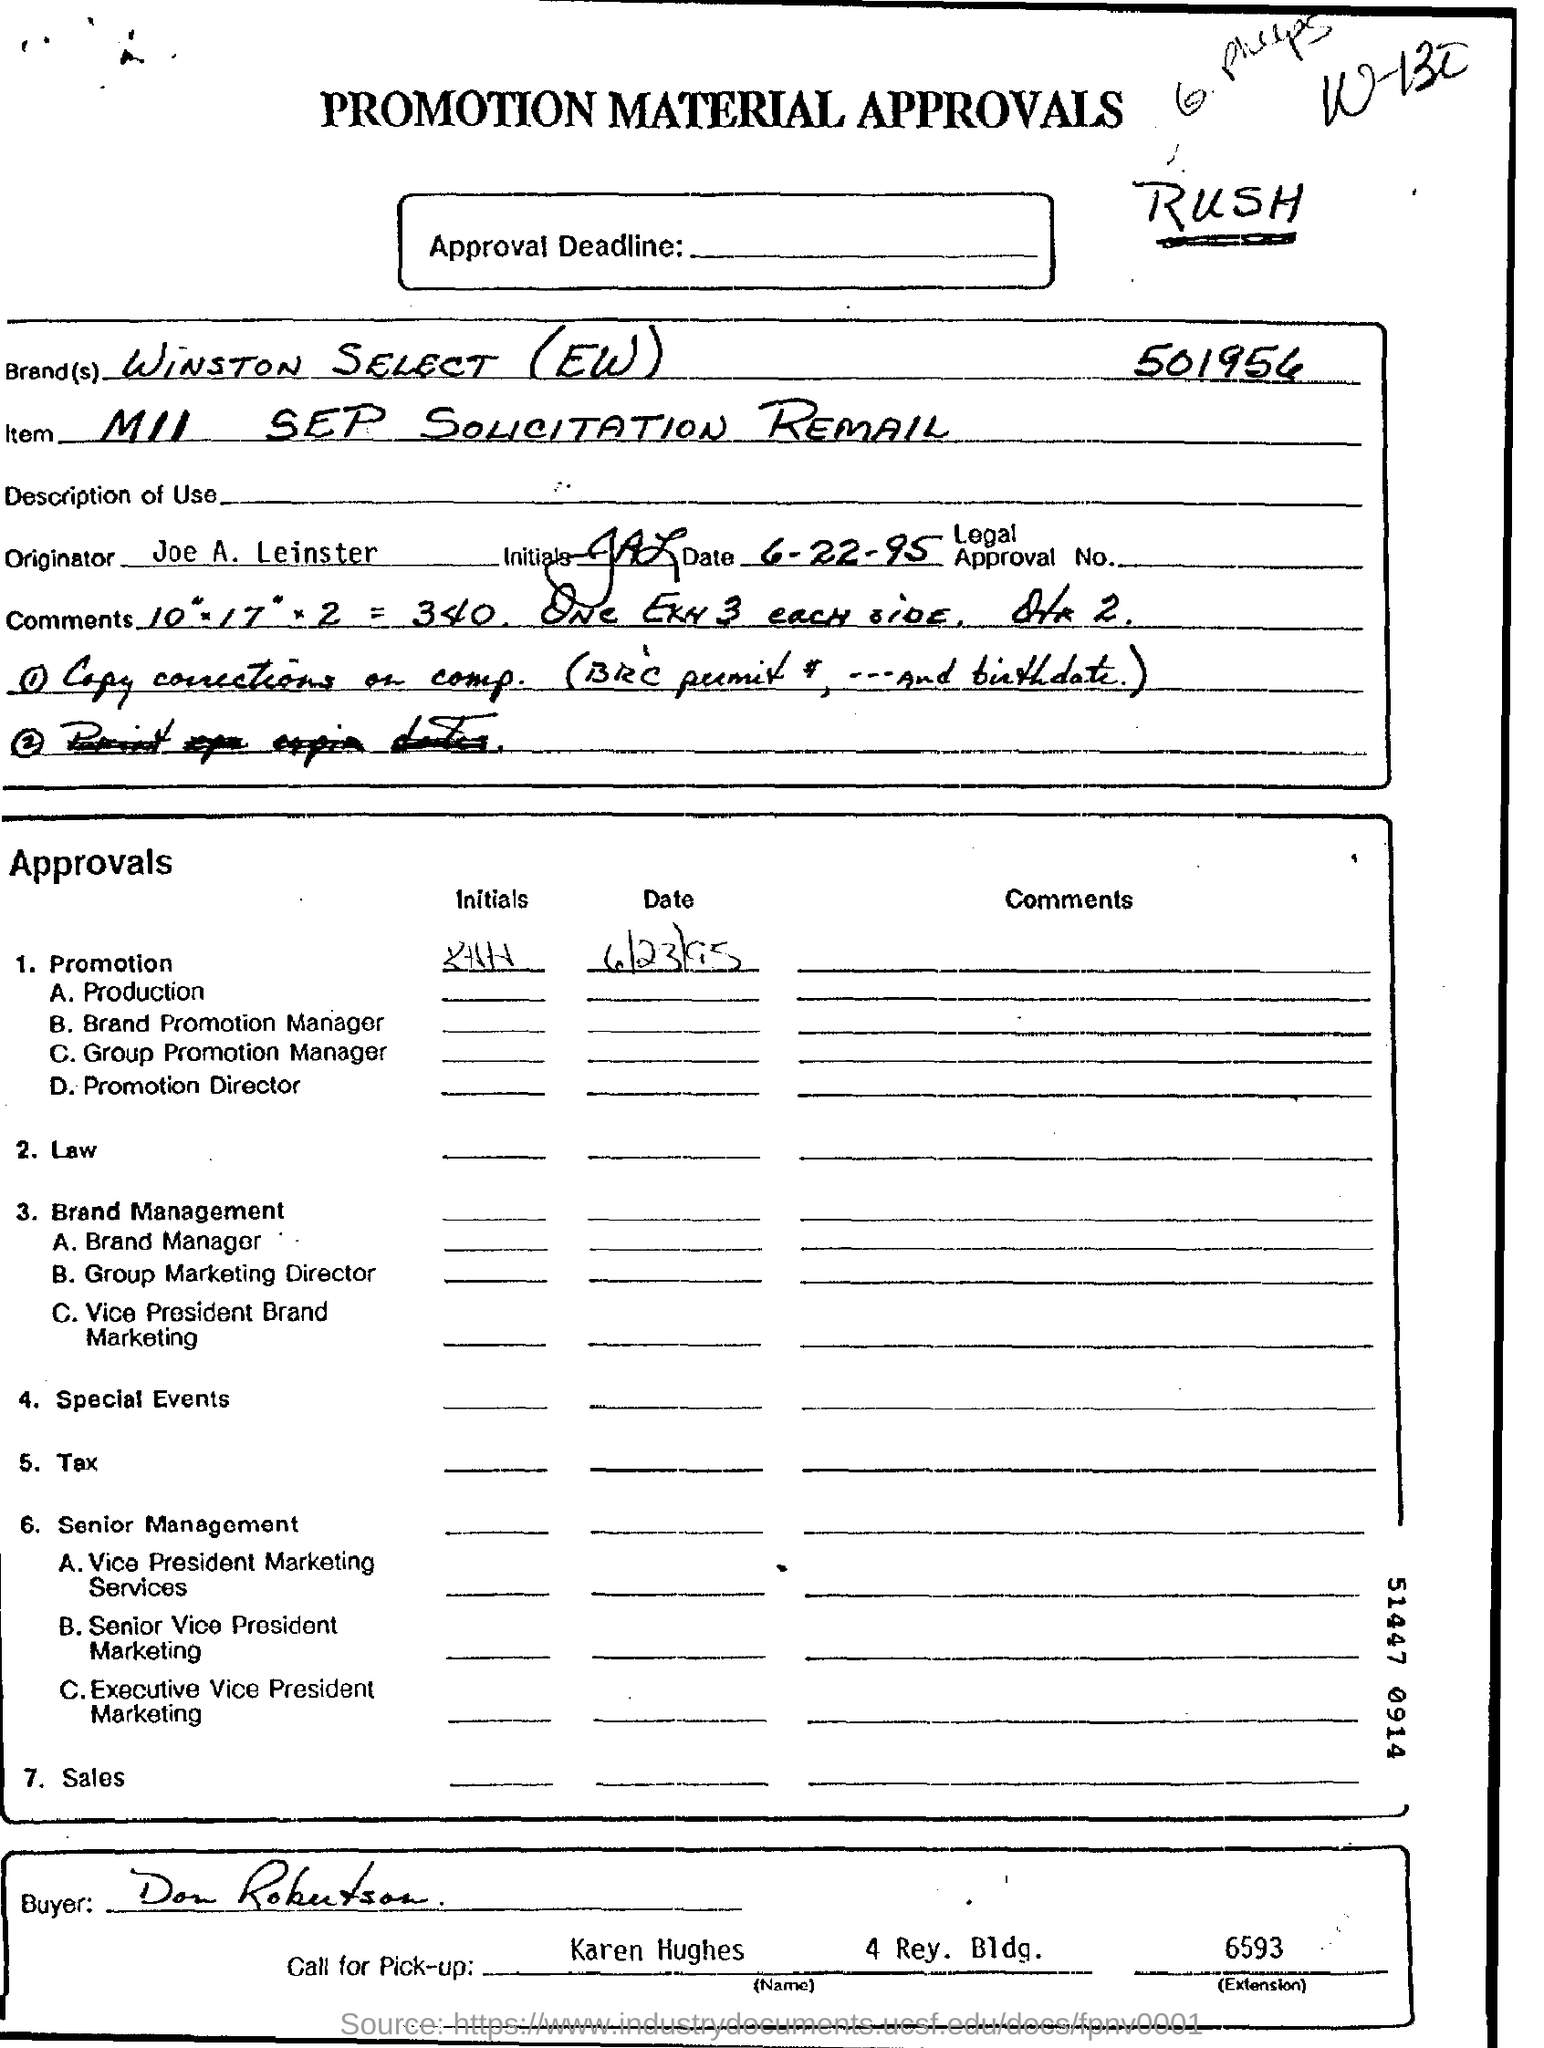What is the name of the brand?
Your answer should be very brief. Winston select(ew). What is the name of the item?
Your answer should be very brief. MII SEP SOLICITATION REMAIL. What is the name of the orginator?
Make the answer very short. Joe A. Leinster. What is the name of the buyer?
Offer a very short reply. Don robutson. 